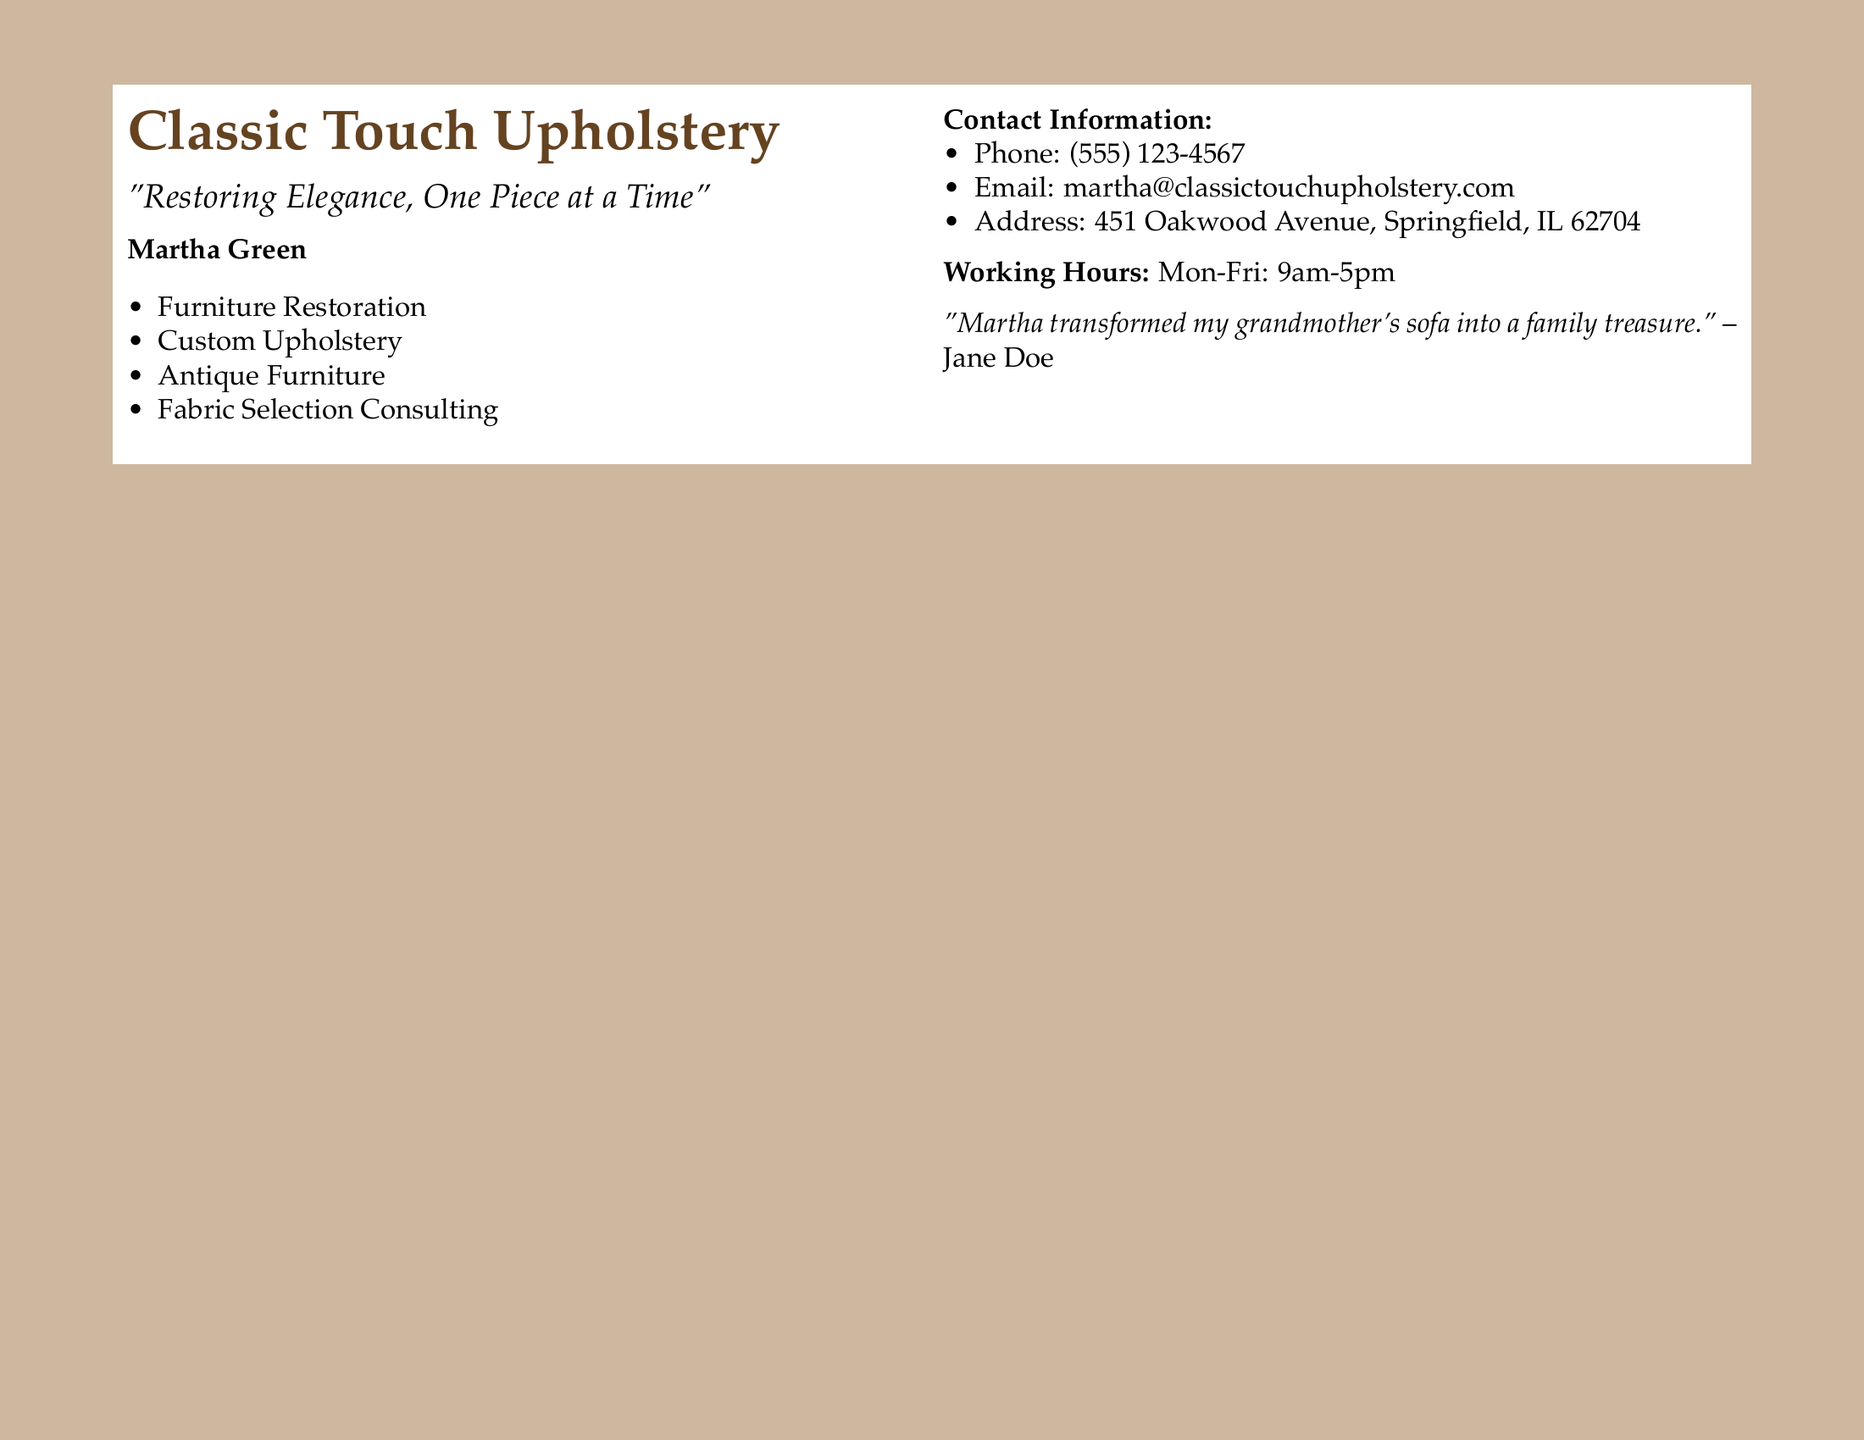What is the name of the upholsterer? The name of the upholsterer is provided in bold, which is Martha Green.
Answer: Martha Green What services does Classic Touch Upholstery offer? The services listed on the card include Furniture Restoration, Custom Upholstery, Antique Furniture, and Fabric Selection Consulting.
Answer: Furniture Restoration, Custom Upholstery, Antique Furniture, Fabric Selection Consulting What is the phone number for contact? The phone number is listed under contact information, which can be found on the right side of the card.
Answer: (555) 123-4567 What is the slogan of Classic Touch Upholstery? The slogan is shown beneath the business name, emphasizing their approach to upholstery.
Answer: "Restoring Elegance, One Piece at a Time" What is the address of Classic Touch Upholstery? The address is detailed in the contact information, specifying the location of the business.
Answer: 451 Oakwood Avenue, Springfield, IL 62704 What are the working hours for Classic Touch Upholstery? The working hours are stated on the business card, indicating when customers can visit or contact.
Answer: Mon-Fri: 9am-5pm Who provided a testimonial for Martha Green? The testimonial is given by a named person, indicating a satisfied customer.
Answer: Jane Doe What type of furniture does Martha specialize in restoring? The document specifies that Martha works with a category of furniture, as noted in her service offerings.
Answer: Antique Furniture What is the background color of the document? The background color is explicitly described in the document margins above the text.
Answer: Vintage 